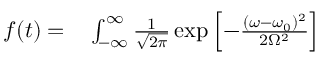Convert formula to latex. <formula><loc_0><loc_0><loc_500><loc_500>\begin{array} { r l } { f ( t ) = } & \int _ { - \infty } ^ { \infty } \frac { 1 } { \sqrt { 2 \pi } } \exp \left [ - \frac { ( \omega - \omega _ { 0 } ) ^ { 2 } } { 2 \Omega ^ { 2 } } \right ] } \end{array}</formula> 